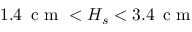Convert formula to latex. <formula><loc_0><loc_0><loc_500><loc_500>1 . 4 \, c m < H _ { s } < 3 . 4 \, c m</formula> 